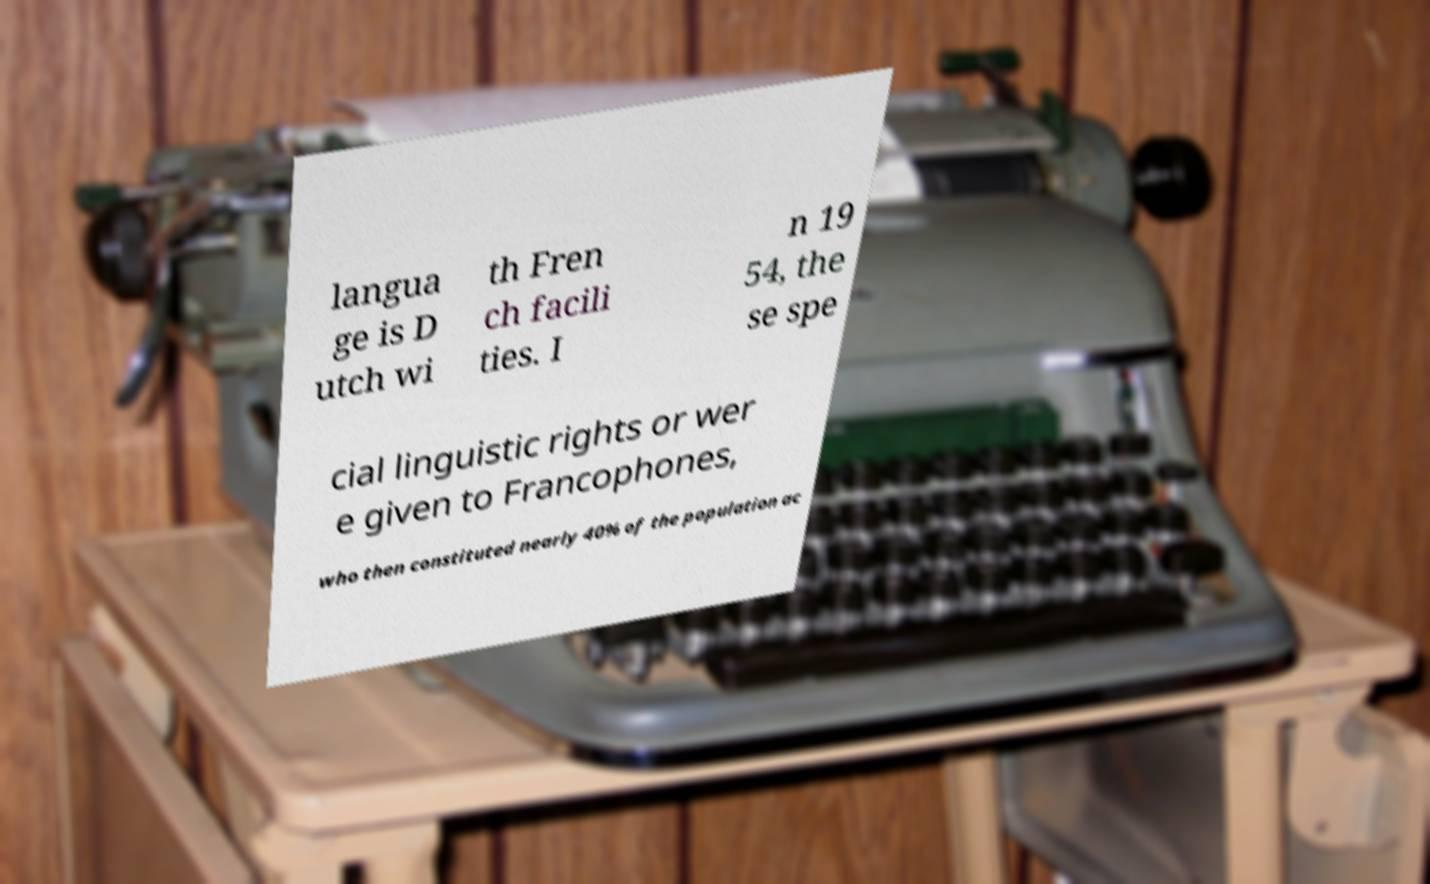I need the written content from this picture converted into text. Can you do that? langua ge is D utch wi th Fren ch facili ties. I n 19 54, the se spe cial linguistic rights or wer e given to Francophones, who then constituted nearly 40% of the population ac 